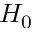Convert formula to latex. <formula><loc_0><loc_0><loc_500><loc_500>H _ { 0 }</formula> 